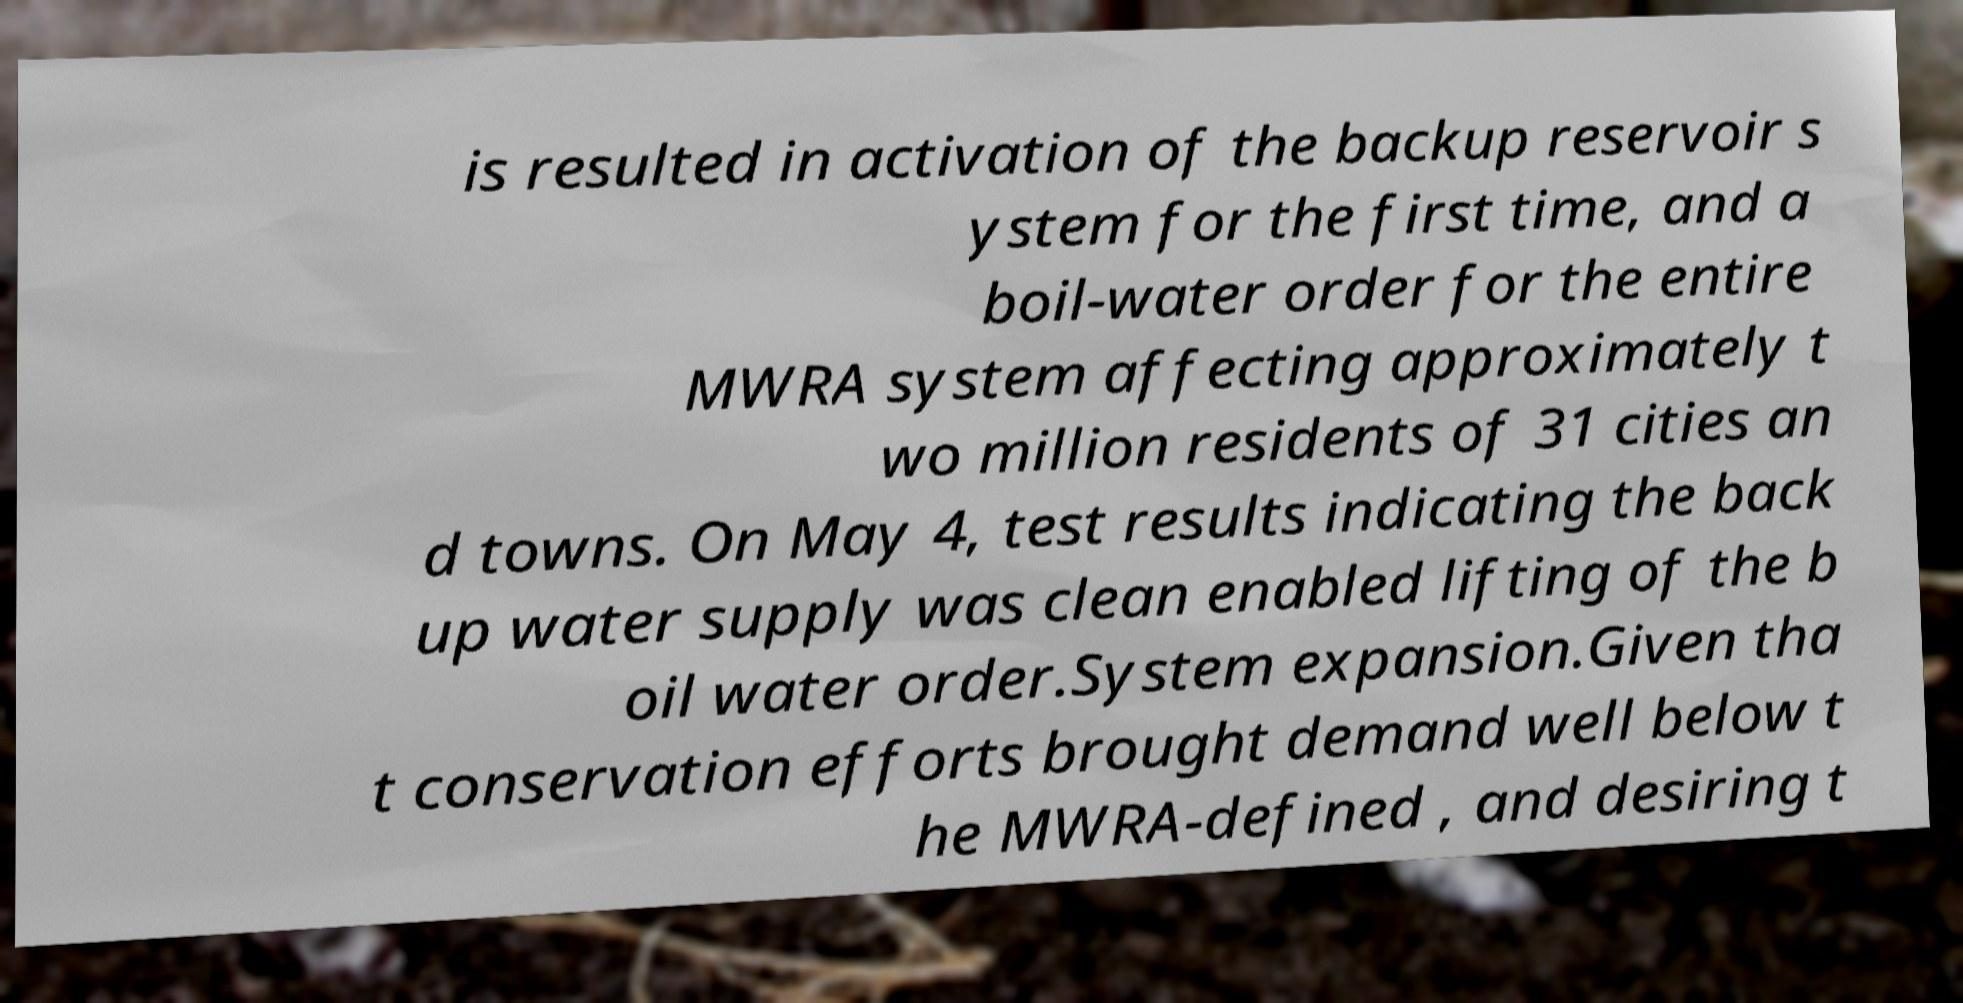Could you extract and type out the text from this image? is resulted in activation of the backup reservoir s ystem for the first time, and a boil-water order for the entire MWRA system affecting approximately t wo million residents of 31 cities an d towns. On May 4, test results indicating the back up water supply was clean enabled lifting of the b oil water order.System expansion.Given tha t conservation efforts brought demand well below t he MWRA-defined , and desiring t 